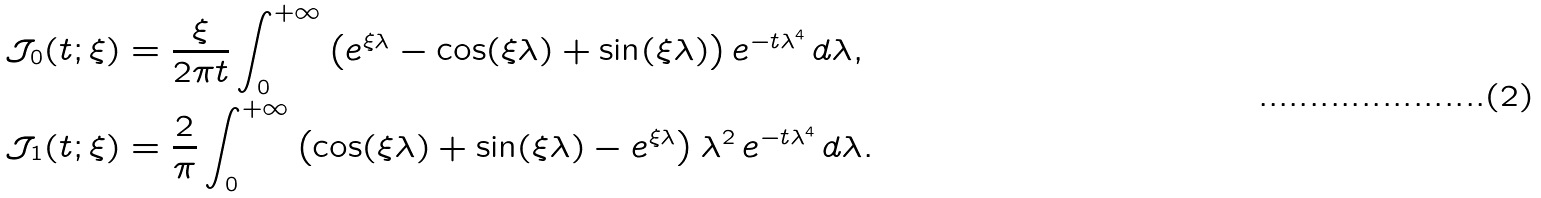Convert formula to latex. <formula><loc_0><loc_0><loc_500><loc_500>\mathcal { J } _ { 0 } ( t ; \xi ) & = \frac { \xi } { 2 \pi t } \int _ { 0 } ^ { + \infty } \left ( e ^ { \xi \lambda } - \cos ( \xi \lambda ) + \sin ( \xi \lambda ) \right ) e ^ { - t \lambda ^ { 4 } } \, d \lambda , \\ \mathcal { J } _ { 1 } ( t ; \xi ) & = \frac { 2 } { \pi } \int _ { 0 } ^ { + \infty } \left ( \cos ( \xi \lambda ) + \sin ( \xi \lambda ) - e ^ { \xi \lambda } \right ) \lambda ^ { 2 } \, e ^ { - t \lambda ^ { 4 } } \, d \lambda .</formula> 